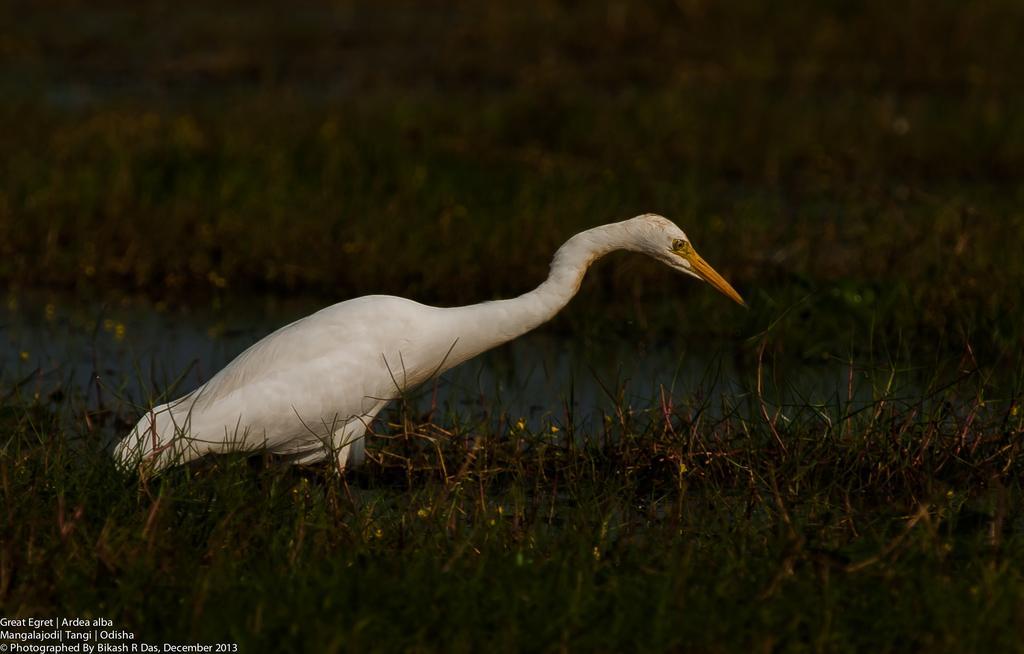In one or two sentences, can you explain what this image depicts? In this picture there is a crane standing in the water. At the bottom there is grass and water. In the bottom left there is a text. 